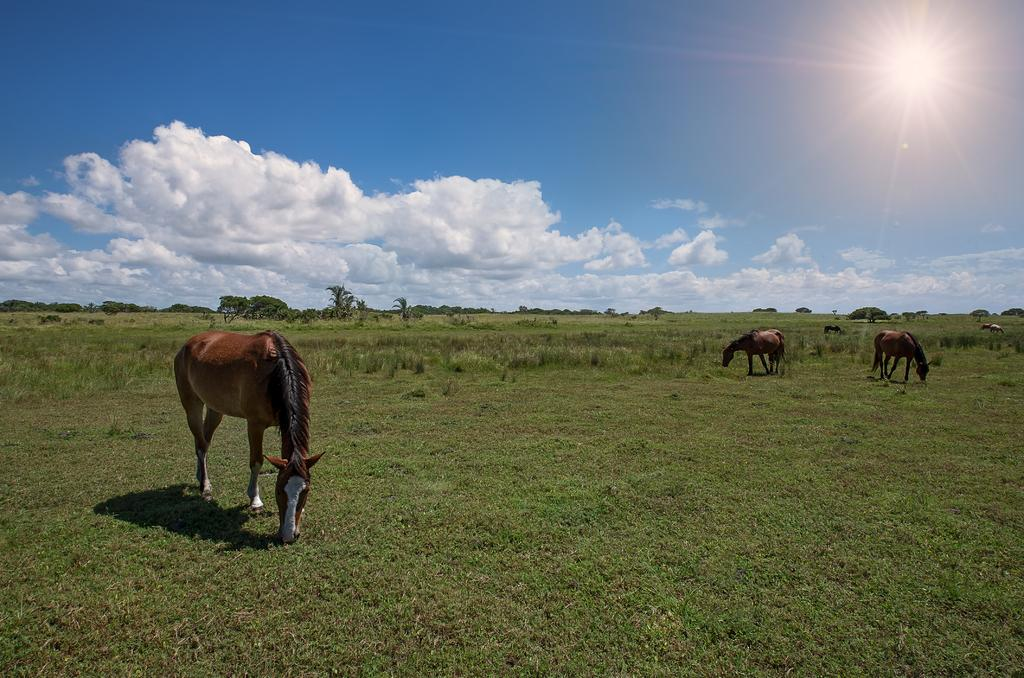What animals can be seen in the image? There are horses in the image. What colors are the horses? The horses are brown and white in color. What type of vegetation is visible in the image? There is grass visible in the image. What else can be seen in the image besides the horses and grass? There are trees in the image. How would you describe the weather in the image? The sky is cloudy in the image, but the sun is also visible. Where is the grain stored in the image? There is no grain present in the image. Can you describe the table in the image? There is no table present in the image. 